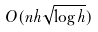Convert formula to latex. <formula><loc_0><loc_0><loc_500><loc_500>O ( n h \sqrt { \log h } )</formula> 